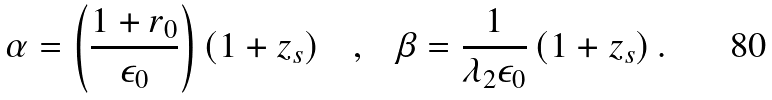Convert formula to latex. <formula><loc_0><loc_0><loc_500><loc_500>\alpha = \left ( \frac { 1 + r _ { 0 } } { \epsilon _ { 0 } } \right ) \left ( 1 + z _ { s } \right ) \text { \ \ } , \text { \ \ } \beta = \frac { 1 } { \lambda _ { 2 } \epsilon _ { 0 } } \left ( 1 + z _ { s } \right ) .</formula> 